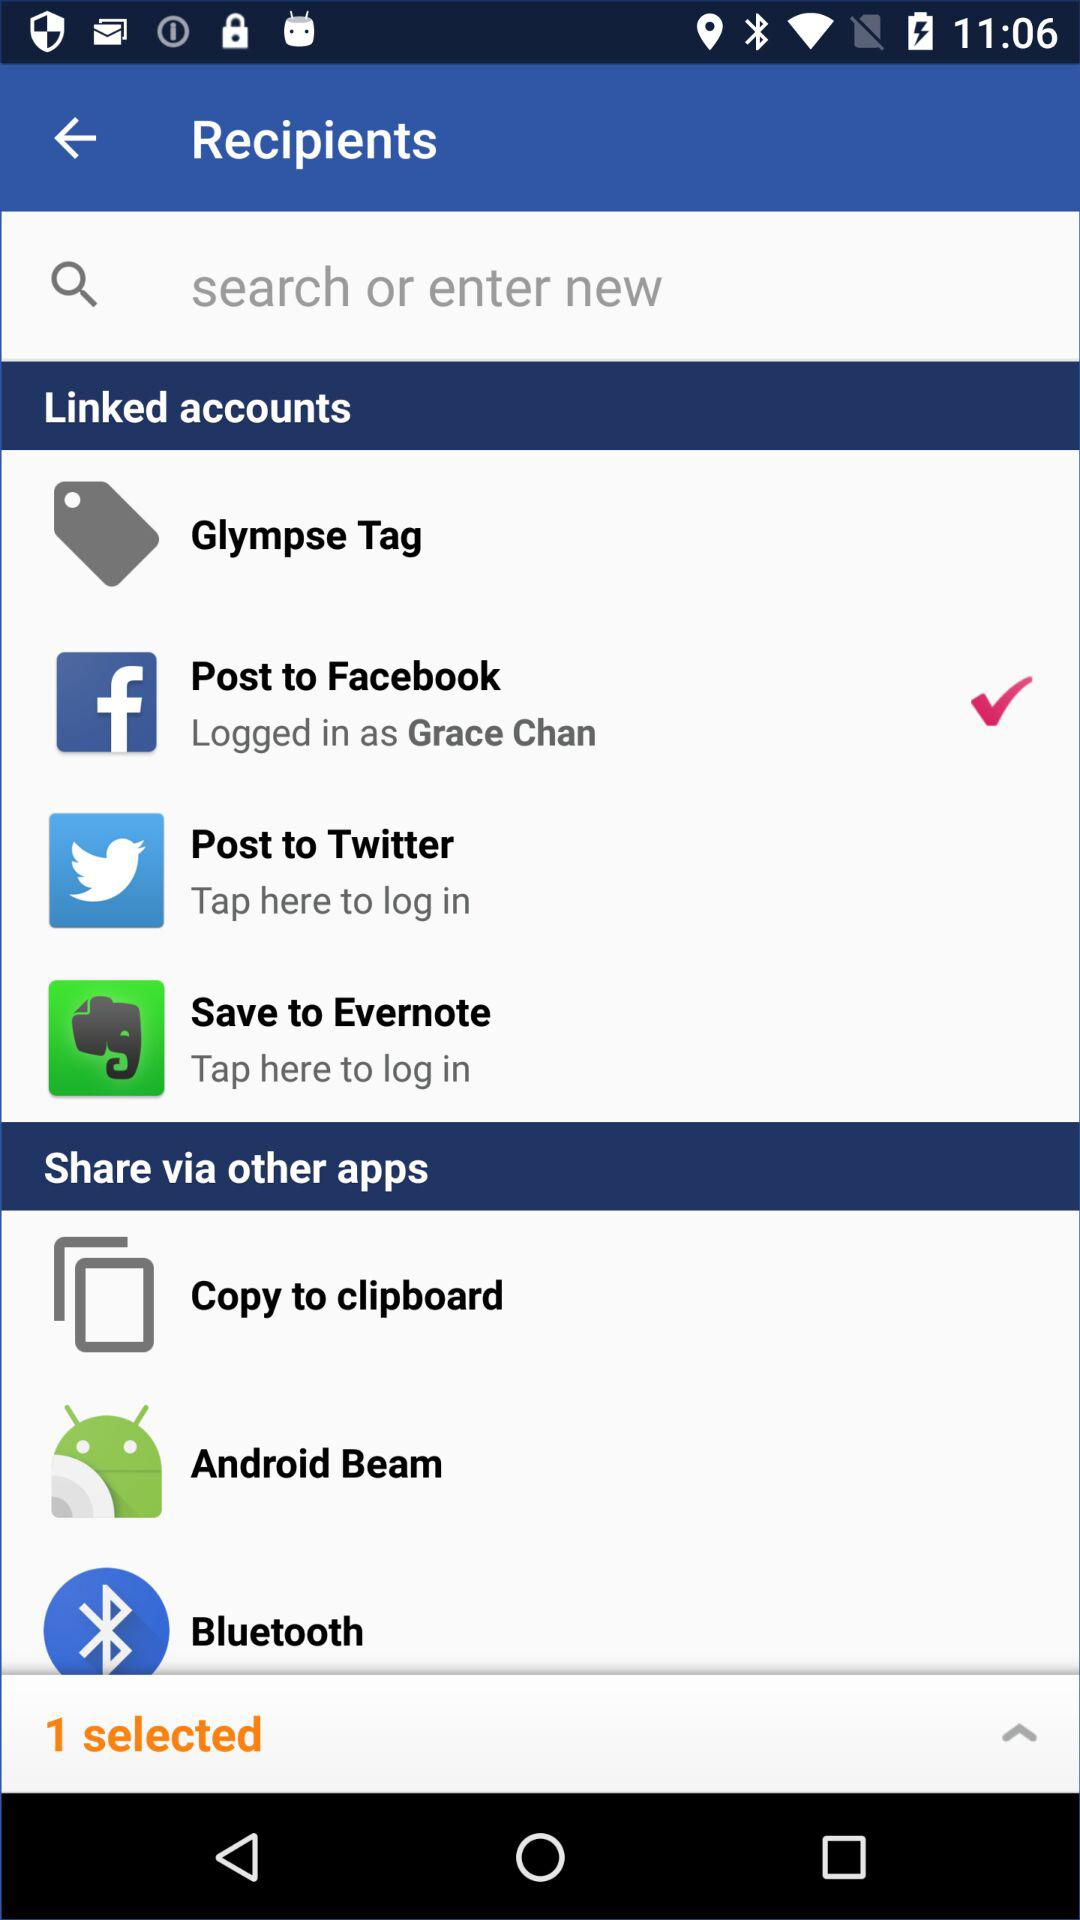How many linked accounts are there?
Answer the question using a single word or phrase. 4 